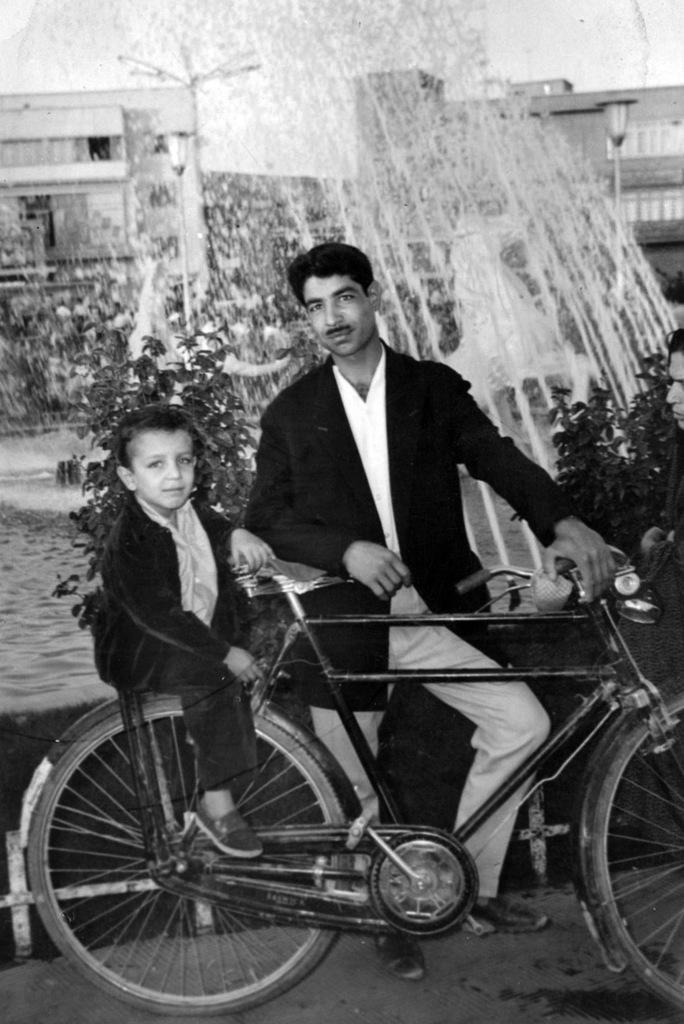Can you describe this image briefly? In this we can see a man wearing black coat and white shirt is standing near the bicycle, And a small boy sitting on the back side of the cycle stand. Behind them there is a water fountain, some plant and houses. 